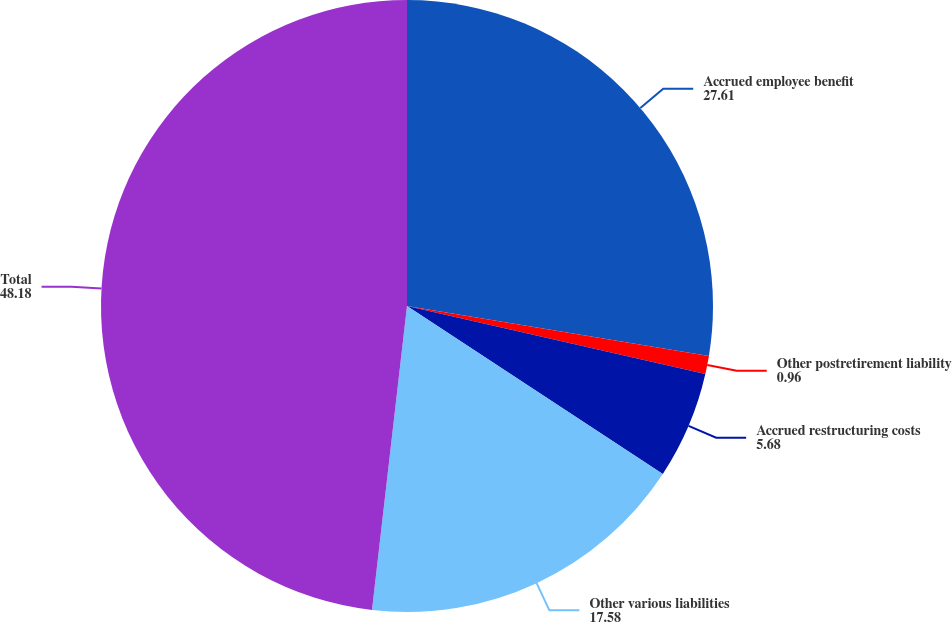Convert chart to OTSL. <chart><loc_0><loc_0><loc_500><loc_500><pie_chart><fcel>Accrued employee benefit<fcel>Other postretirement liability<fcel>Accrued restructuring costs<fcel>Other various liabilities<fcel>Total<nl><fcel>27.61%<fcel>0.96%<fcel>5.68%<fcel>17.58%<fcel>48.18%<nl></chart> 